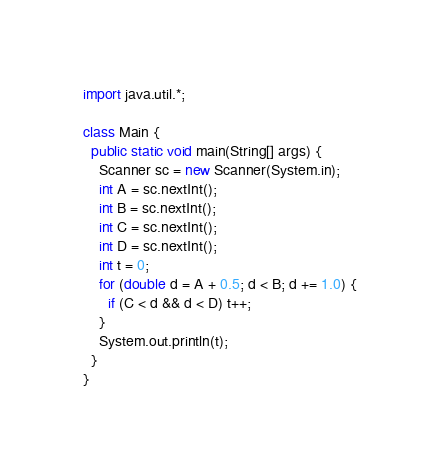<code> <loc_0><loc_0><loc_500><loc_500><_Java_>import java.util.*;

class Main {
  public static void main(String[] args) {
    Scanner sc = new Scanner(System.in);
    int A = sc.nextInt();
    int B = sc.nextInt();
    int C = sc.nextInt();
    int D = sc.nextInt();
    int t = 0;
    for (double d = A + 0.5; d < B; d += 1.0) {
      if (C < d && d < D) t++;
    }
    System.out.println(t);
  }
}
</code> 